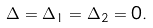Convert formula to latex. <formula><loc_0><loc_0><loc_500><loc_500>\Delta = \Delta _ { 1 } = \Delta _ { 2 } = 0 .</formula> 